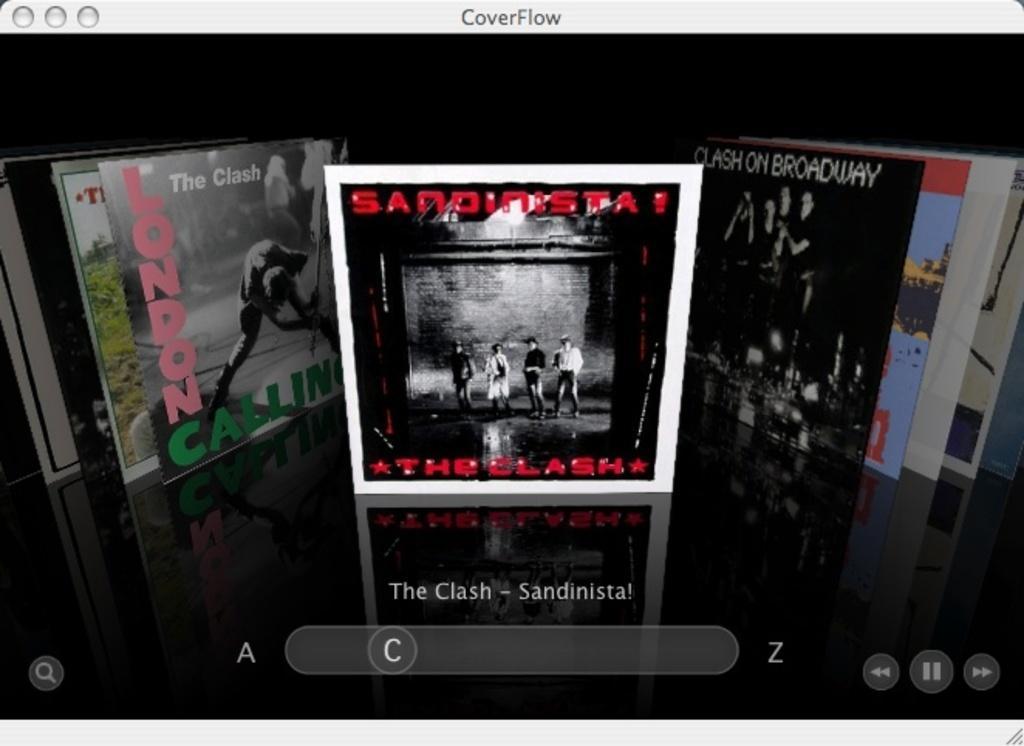In one or two sentences, can you explain what this image depicts? This is an animated image in this image in the center there are some books, and at the bottom of the image there is some text written and on the top of the image there is some text. 